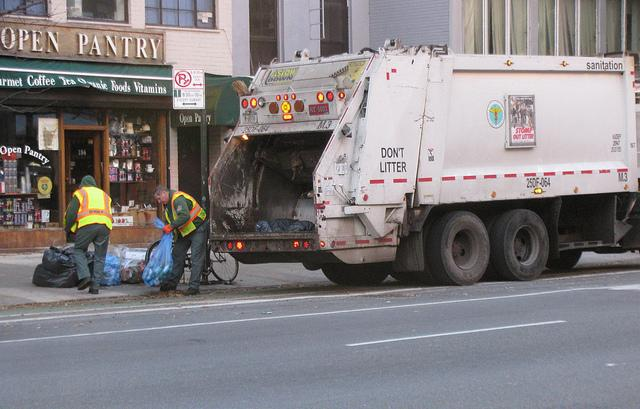Why are the men wearing yellow vests? Please explain your reasoning. visibility. The bright colors will be easily spotted by motorists and lessen the chance of them getting hit. 